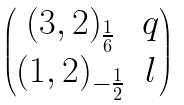Convert formula to latex. <formula><loc_0><loc_0><loc_500><loc_500>\begin{pmatrix} ( 3 , 2 ) _ { \frac { 1 } { 6 } } & q \\ ( 1 , 2 ) _ { - \frac { 1 } { 2 } } & l \end{pmatrix}</formula> 